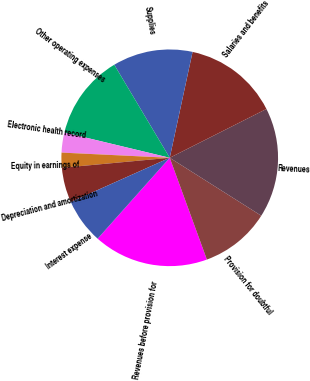Convert chart to OTSL. <chart><loc_0><loc_0><loc_500><loc_500><pie_chart><fcel>Revenues before provision for<fcel>Provision for doubtful<fcel>Revenues<fcel>Salaries and benefits<fcel>Supplies<fcel>Other operating expenses<fcel>Electronic health record<fcel>Equity in earnings of<fcel>Depreciation and amortization<fcel>Interest expense<nl><fcel>17.16%<fcel>10.45%<fcel>16.42%<fcel>14.18%<fcel>11.94%<fcel>12.69%<fcel>2.99%<fcel>2.24%<fcel>5.22%<fcel>6.72%<nl></chart> 